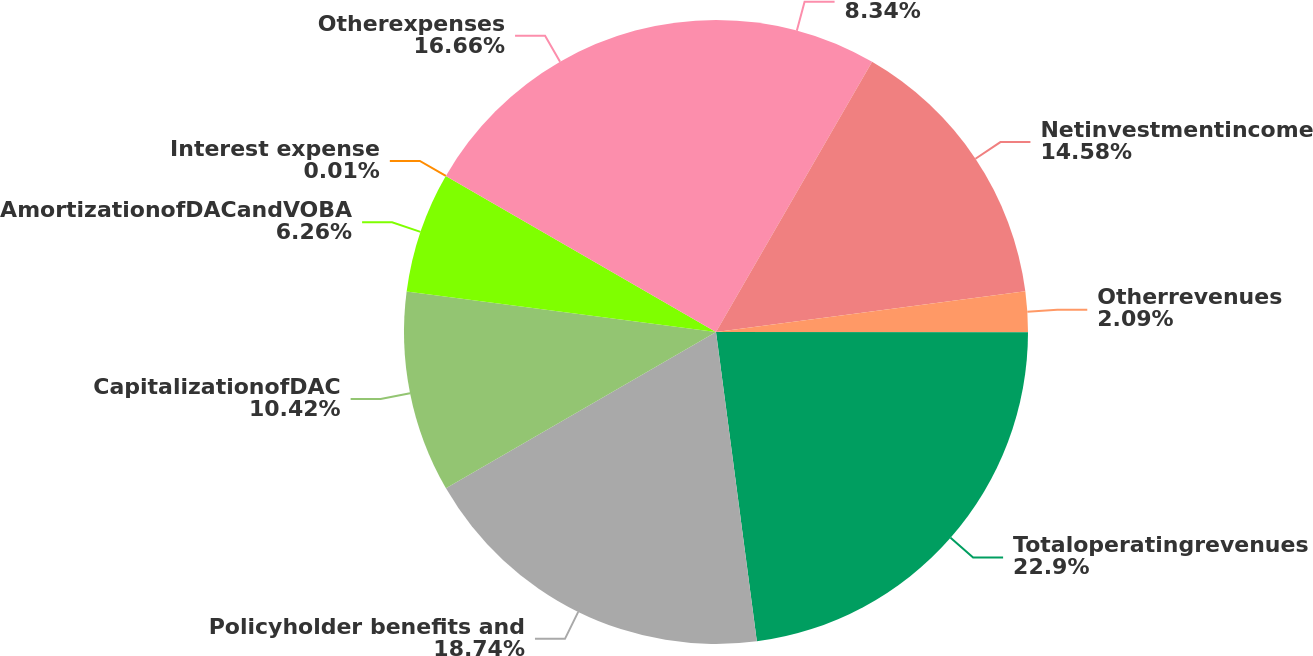Convert chart. <chart><loc_0><loc_0><loc_500><loc_500><pie_chart><ecel><fcel>Netinvestmentincome<fcel>Otherrevenues<fcel>Totaloperatingrevenues<fcel>Policyholder benefits and<fcel>CapitalizationofDAC<fcel>AmortizationofDACandVOBA<fcel>Interest expense<fcel>Otherexpenses<nl><fcel>8.34%<fcel>14.58%<fcel>2.09%<fcel>22.9%<fcel>18.74%<fcel>10.42%<fcel>6.26%<fcel>0.01%<fcel>16.66%<nl></chart> 